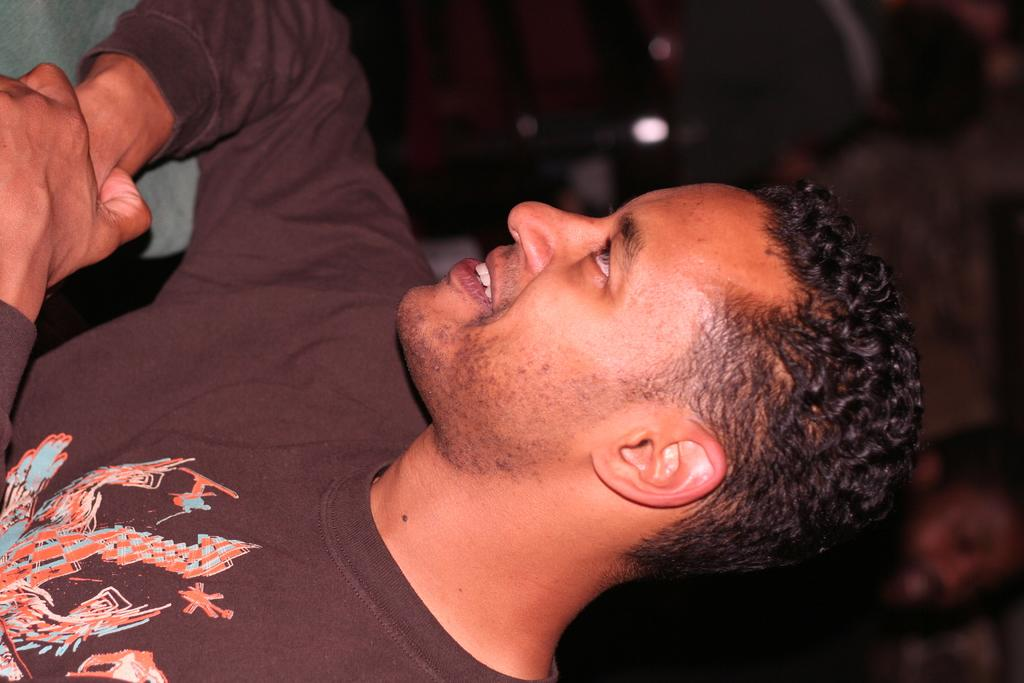Who is present in the image? There is a man in the image. What is the man wearing in the image? The man is wearing a brown T-shirt. Can you describe the background of the image? The background of the image is blurred. What type of paper is the man holding in the image? There is no paper present in the image; the man is not holding anything. 